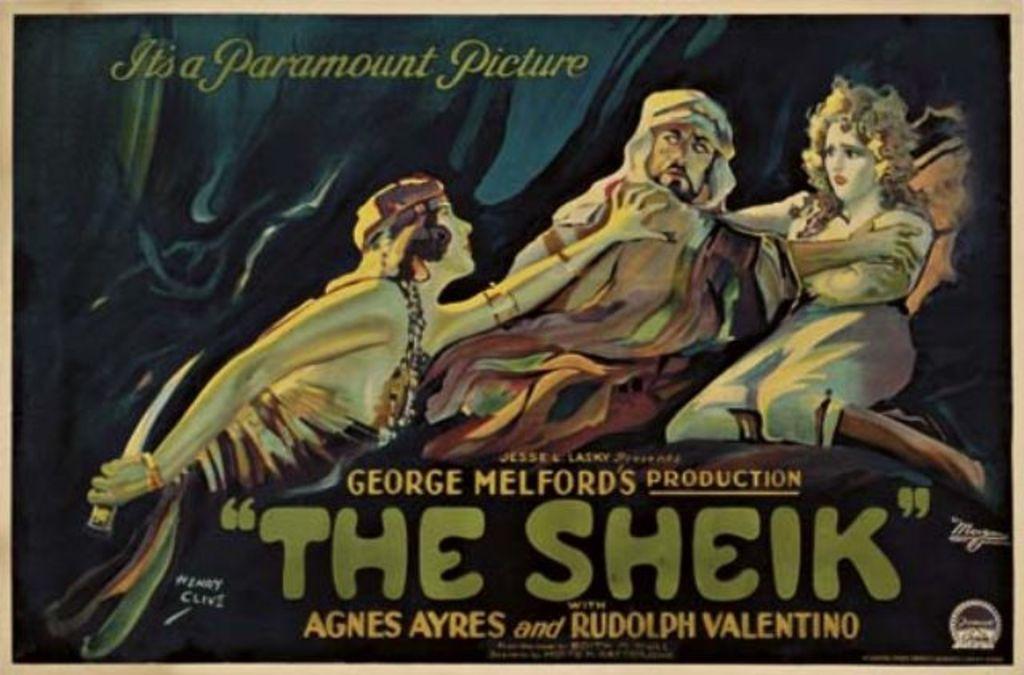What is the title of this film?
Provide a short and direct response. The sheik. 